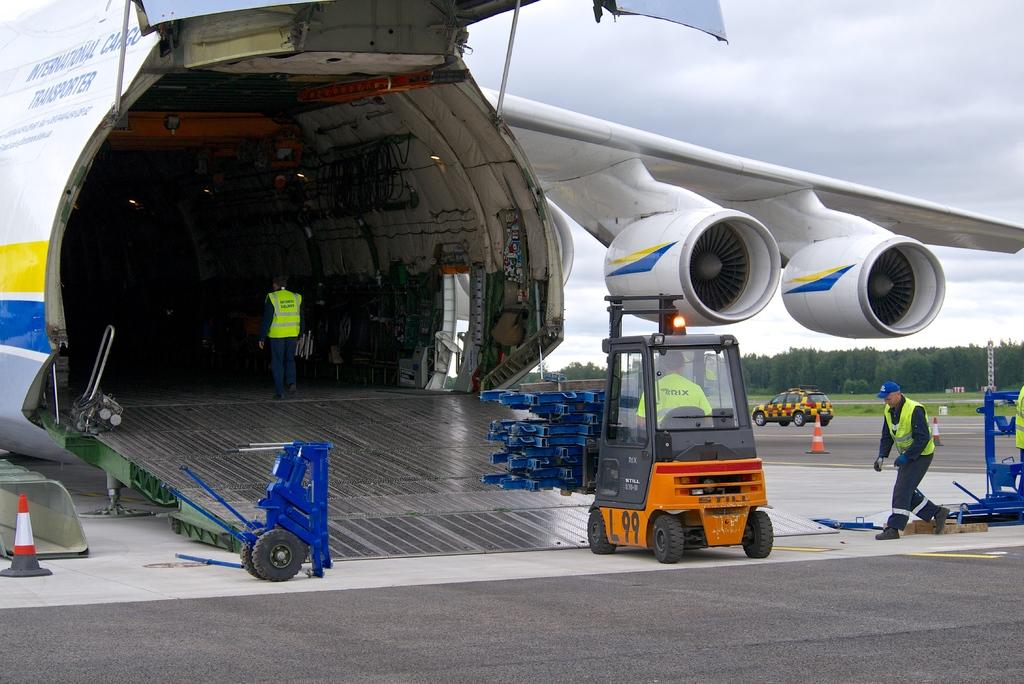<image>
Share a concise interpretation of the image provided. International Cargo Transporter is written on the side of the large cargo plane. 